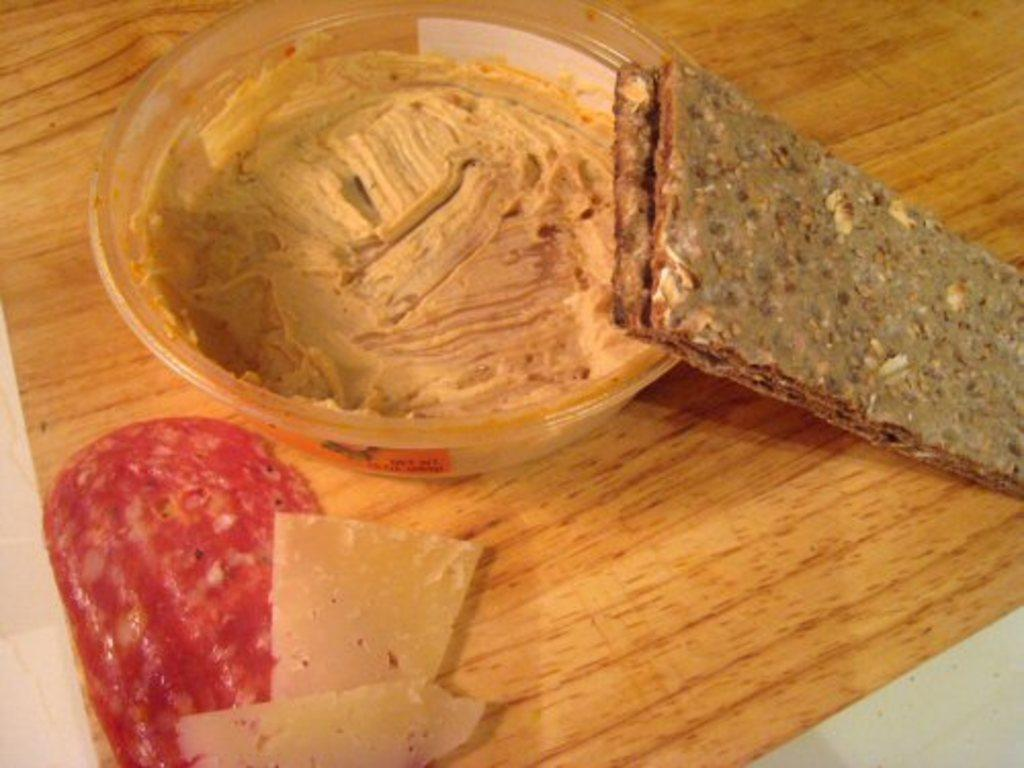What type of food is present in the image? There are creams in a plate in the image. Where is the food located in the image? The food is on a table in the image. What type of business is being conducted in the image? There is no indication of any business being conducted in the image; it primarily features food on a table. 